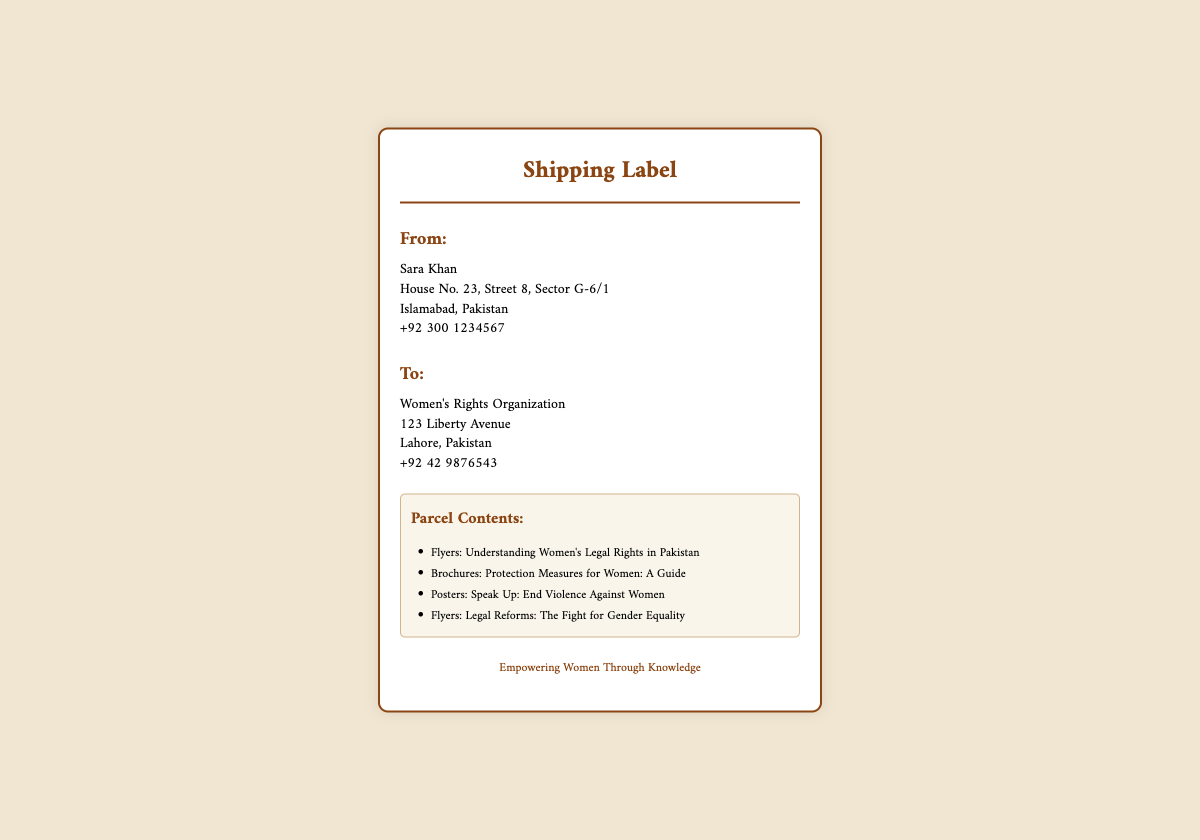what is the sender's name? The sender's name is provided in the address section, which is Sara Khan.
Answer: Sara Khan what is the sender's phone number? The sender's phone number is listed under the sender's address, which is +92 300 1234567.
Answer: +92 300 1234567 what is the recipient's organization? The recipient's organization is mentioned in the "To" address section as Women's Rights Organization.
Answer: Women's Rights Organization where is the recipient located? The recipient's address details include the location of Lahore, Pakistan.
Answer: Lahore, Pakistan how many types of literature are included in the parcel? The document lists four different types of literature under the "Parcel Contents" section.
Answer: Four what is one of the topics covered in the brochures? The brochures cover the topic "Protection Measures for Women: A Guide."
Answer: Protection Measures for Women: A Guide which city is the sender located in? The sender's address indicates that they are located in Islamabad.
Answer: Islamabad what is the main purpose of the parcel? Based on the parcel contents and footer, the main purpose is to empower women through knowledge.
Answer: Empowering Women Through Knowledge 